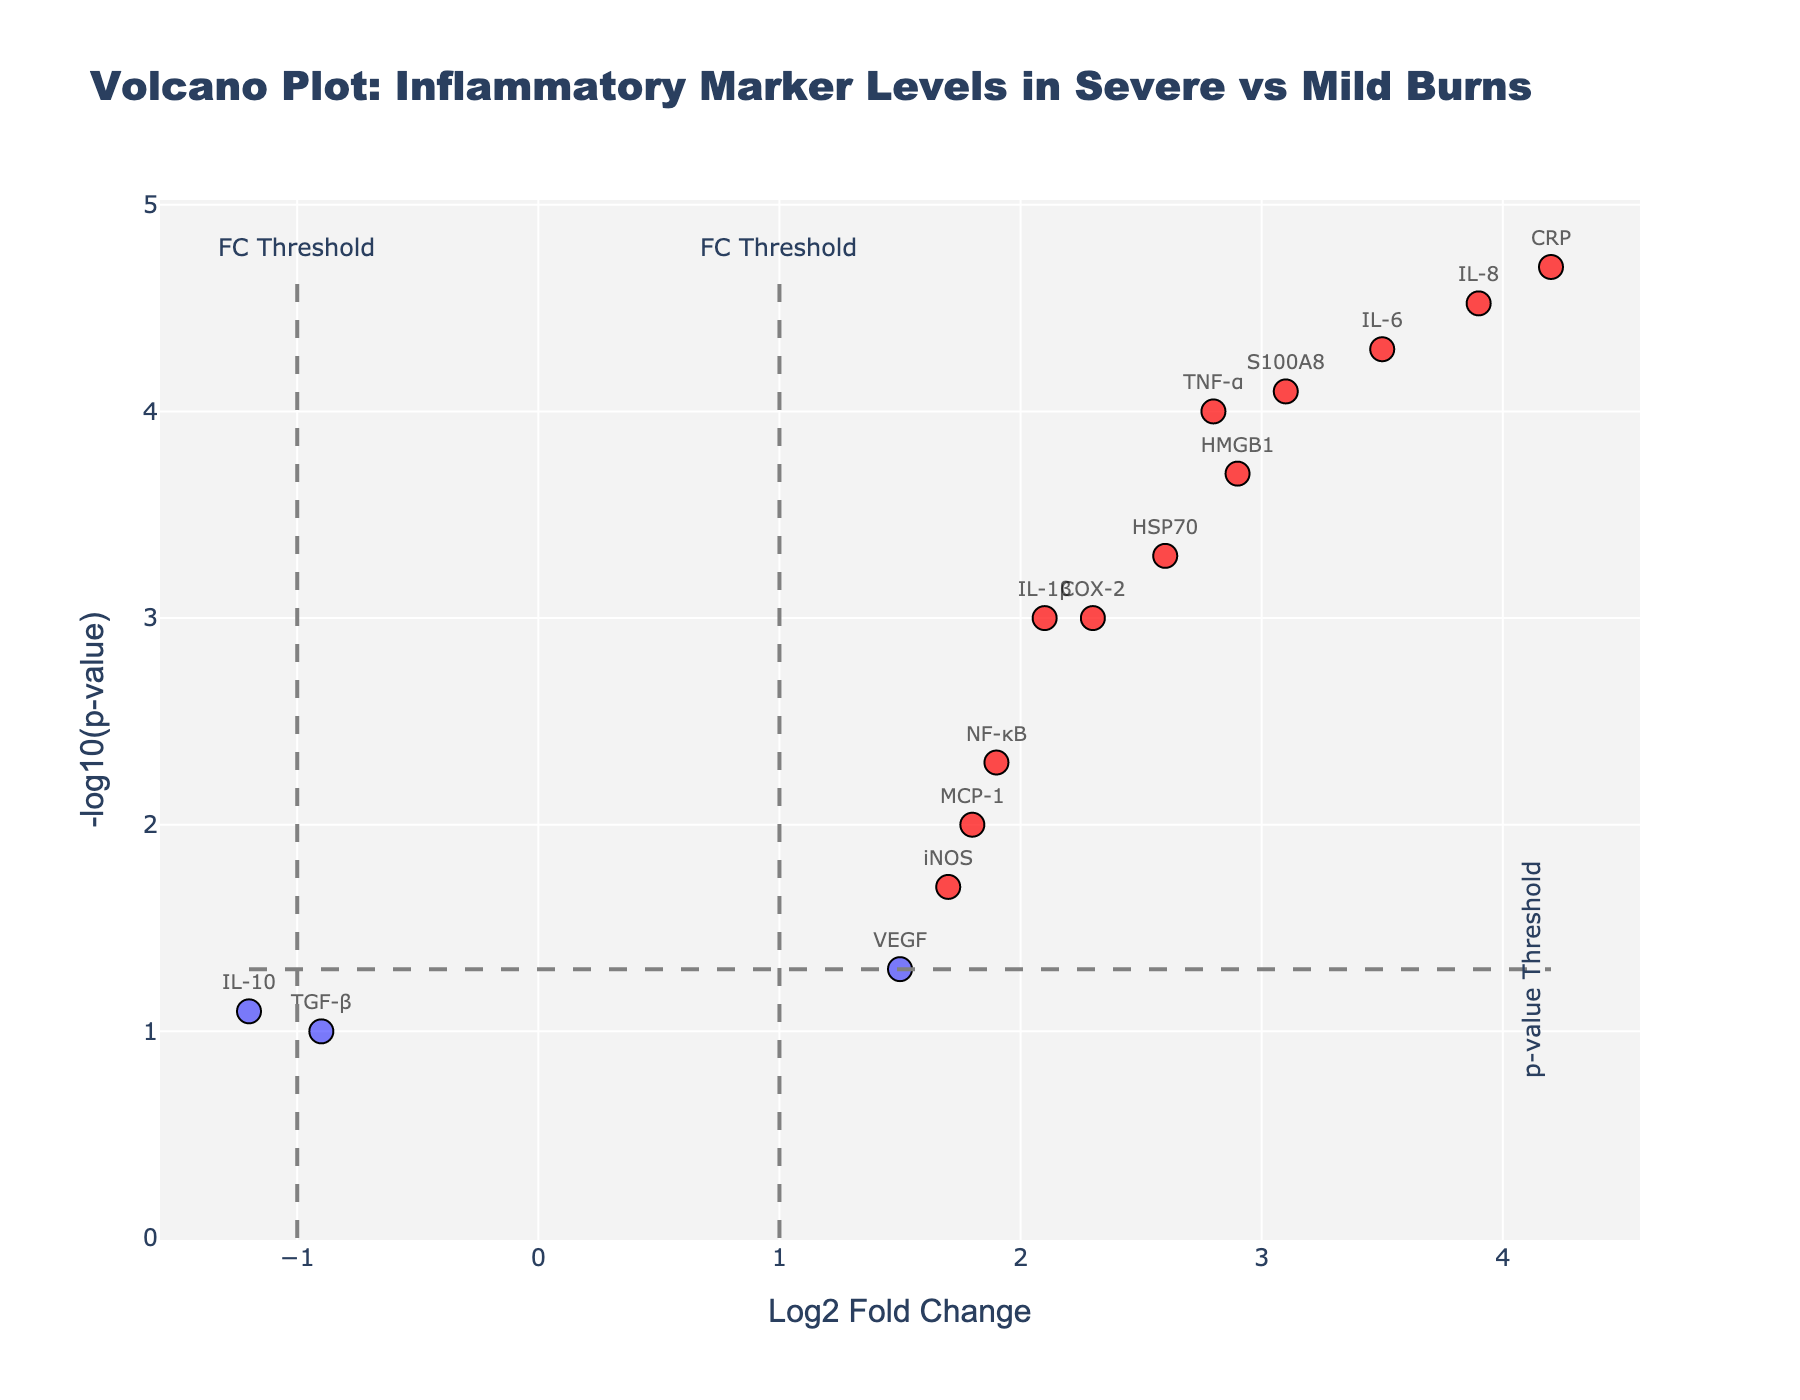Which gene has the highest log2 fold change? Look for the gene with the highest value on the x-axis (Log2 Fold Change). CRP has the highest log2 fold change at 4.2.
Answer: CRP How many genes have a log2 fold change greater than 2? Count the data points on the plot with an x-axis value greater than 2. Genes with Log2FC > 2 are TNF-α, IL-6, CRP, IL-8, HSP70, HMGB1, and S100A8.
Answer: 7 What is the approximate p-value threshold indicated on the plot? The horizontal dashed line on the plot marks the -log10(p-value) threshold. The y-axis value of this line can be converted back to a p-value. The threshold is -log10(0.05), which is approximately 1.3.
Answer: 0.05 Which genes are considered statistically significant and upregulated in severe burns? Statistically significant genes are those above the p-value threshold line, and upregulated genes have a positive log2 fold change (right side of the vertical lines). These include TNF-α, IL-6, CRP, IL-1β, IL-8, HSP70, COX-2, HMGB1, and S100A8.
Answer: TNF-α, IL-6, CRP, IL-1β, IL-8, HSP70, COX-2, HMGB1, S100A8 Does TGF-β show significant upregulation or downregulation in severe burns? Locate TGF-β on the plot and check if it lies beyond both the log2 fold change and p-value thresholds. TGF-β does not cross these thresholds.
Answer: No How many genes are both statistically significant and downregulated? Count the data points on the left side of the plot above the p-value threshold line (red points). None of the data points in the figure meet these criteria.
Answer: 0 Which gene shows the smallest p-value? The smallest p-value corresponds to the highest -log10(p-value). Identify the gene with the highest value on the y-axis. IL-6 has the smallest p-value.
Answer: IL-6 